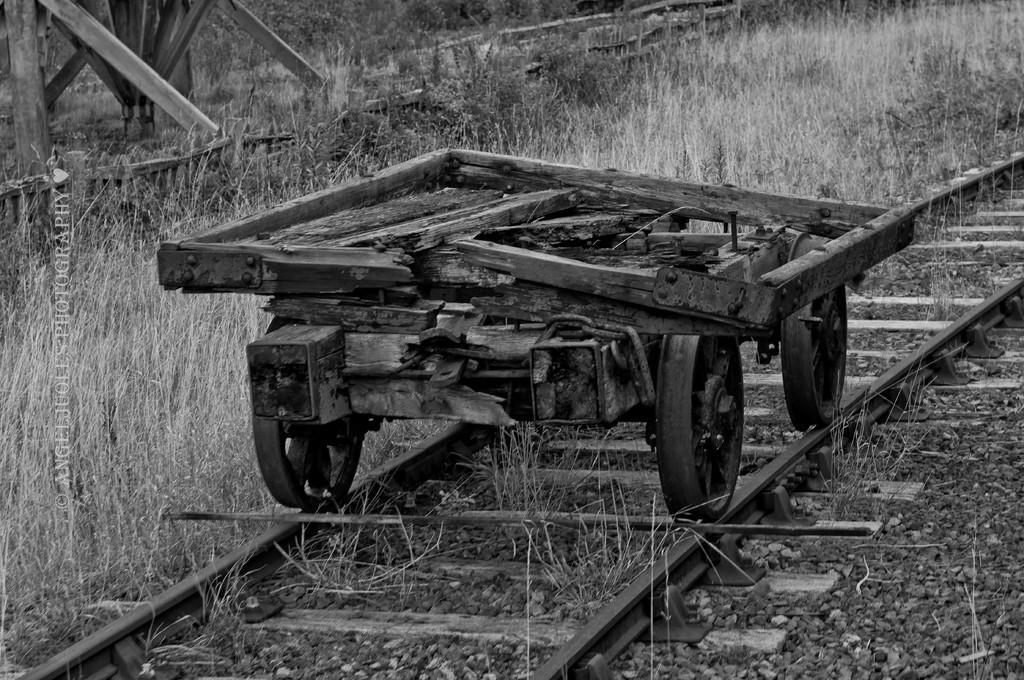What is the main subject of the image? The main subject of the image is a broken vehicle on the railway track. What is placed in front of the broken vehicle? There is a stick in front of the broken vehicle. What type of vegetation is visible near the broken vehicle? There is grass beside the broken vehicle. What language is spoken by the sponge in the image? There is no sponge present in the image, so it is not possible to determine what language it might speak. 